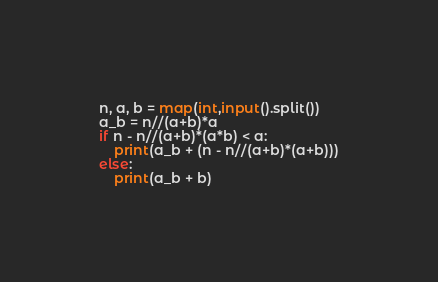Convert code to text. <code><loc_0><loc_0><loc_500><loc_500><_Python_>n, a, b = map(int,input().split())
a_b = n//(a+b)*a
if n - n//(a+b)*(a*b) < a:
    print(a_b + (n - n//(a+b)*(a+b)))
else:
    print(a_b + b)</code> 